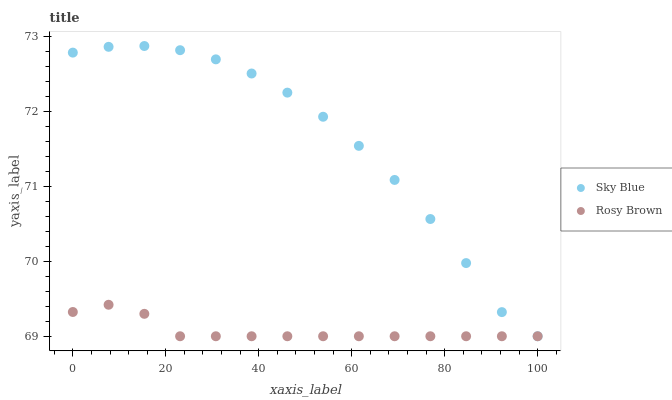Does Rosy Brown have the minimum area under the curve?
Answer yes or no. Yes. Does Sky Blue have the maximum area under the curve?
Answer yes or no. Yes. Does Rosy Brown have the maximum area under the curve?
Answer yes or no. No. Is Rosy Brown the smoothest?
Answer yes or no. Yes. Is Sky Blue the roughest?
Answer yes or no. Yes. Is Rosy Brown the roughest?
Answer yes or no. No. Does Sky Blue have the lowest value?
Answer yes or no. Yes. Does Sky Blue have the highest value?
Answer yes or no. Yes. Does Rosy Brown have the highest value?
Answer yes or no. No. Does Sky Blue intersect Rosy Brown?
Answer yes or no. Yes. Is Sky Blue less than Rosy Brown?
Answer yes or no. No. Is Sky Blue greater than Rosy Brown?
Answer yes or no. No. 